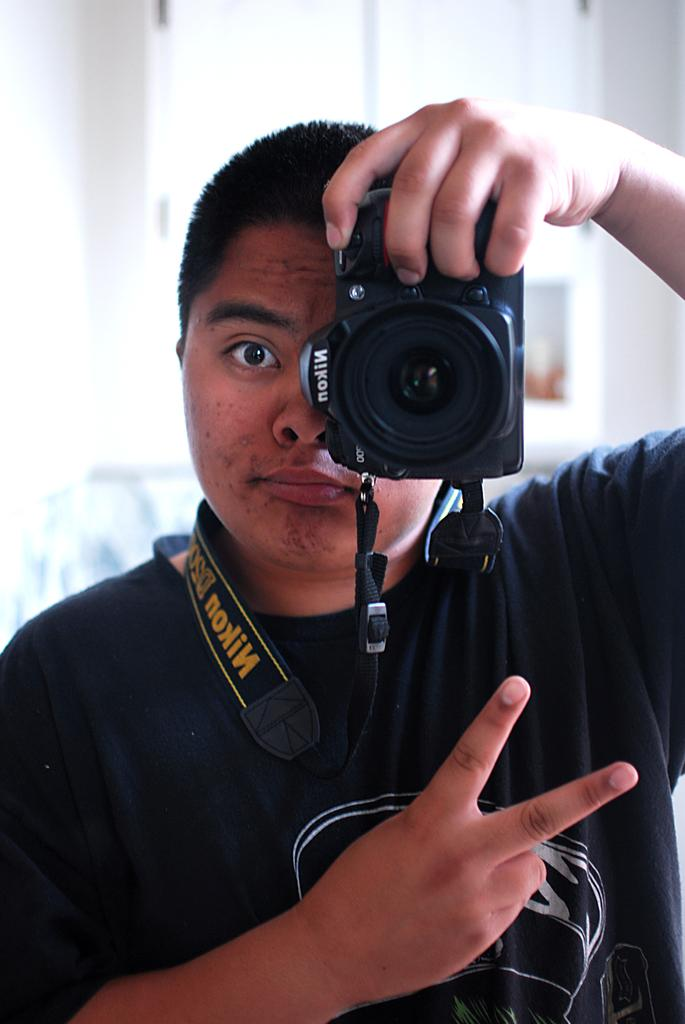What is the man in the image doing? The man is standing in the image. What is the man wearing? The man is wearing a black T-shirt. What is the man holding in his hand? The man is holding a camera in his hand. What can be seen in the background of the image? There is a cupboard in the background of the image. What color is the cupboard? The cupboard is white in color. How many pears are on the cupboard in the image? There are no pears present in the image. What type of horse can be seen in the image? There are no horses present in the image. 